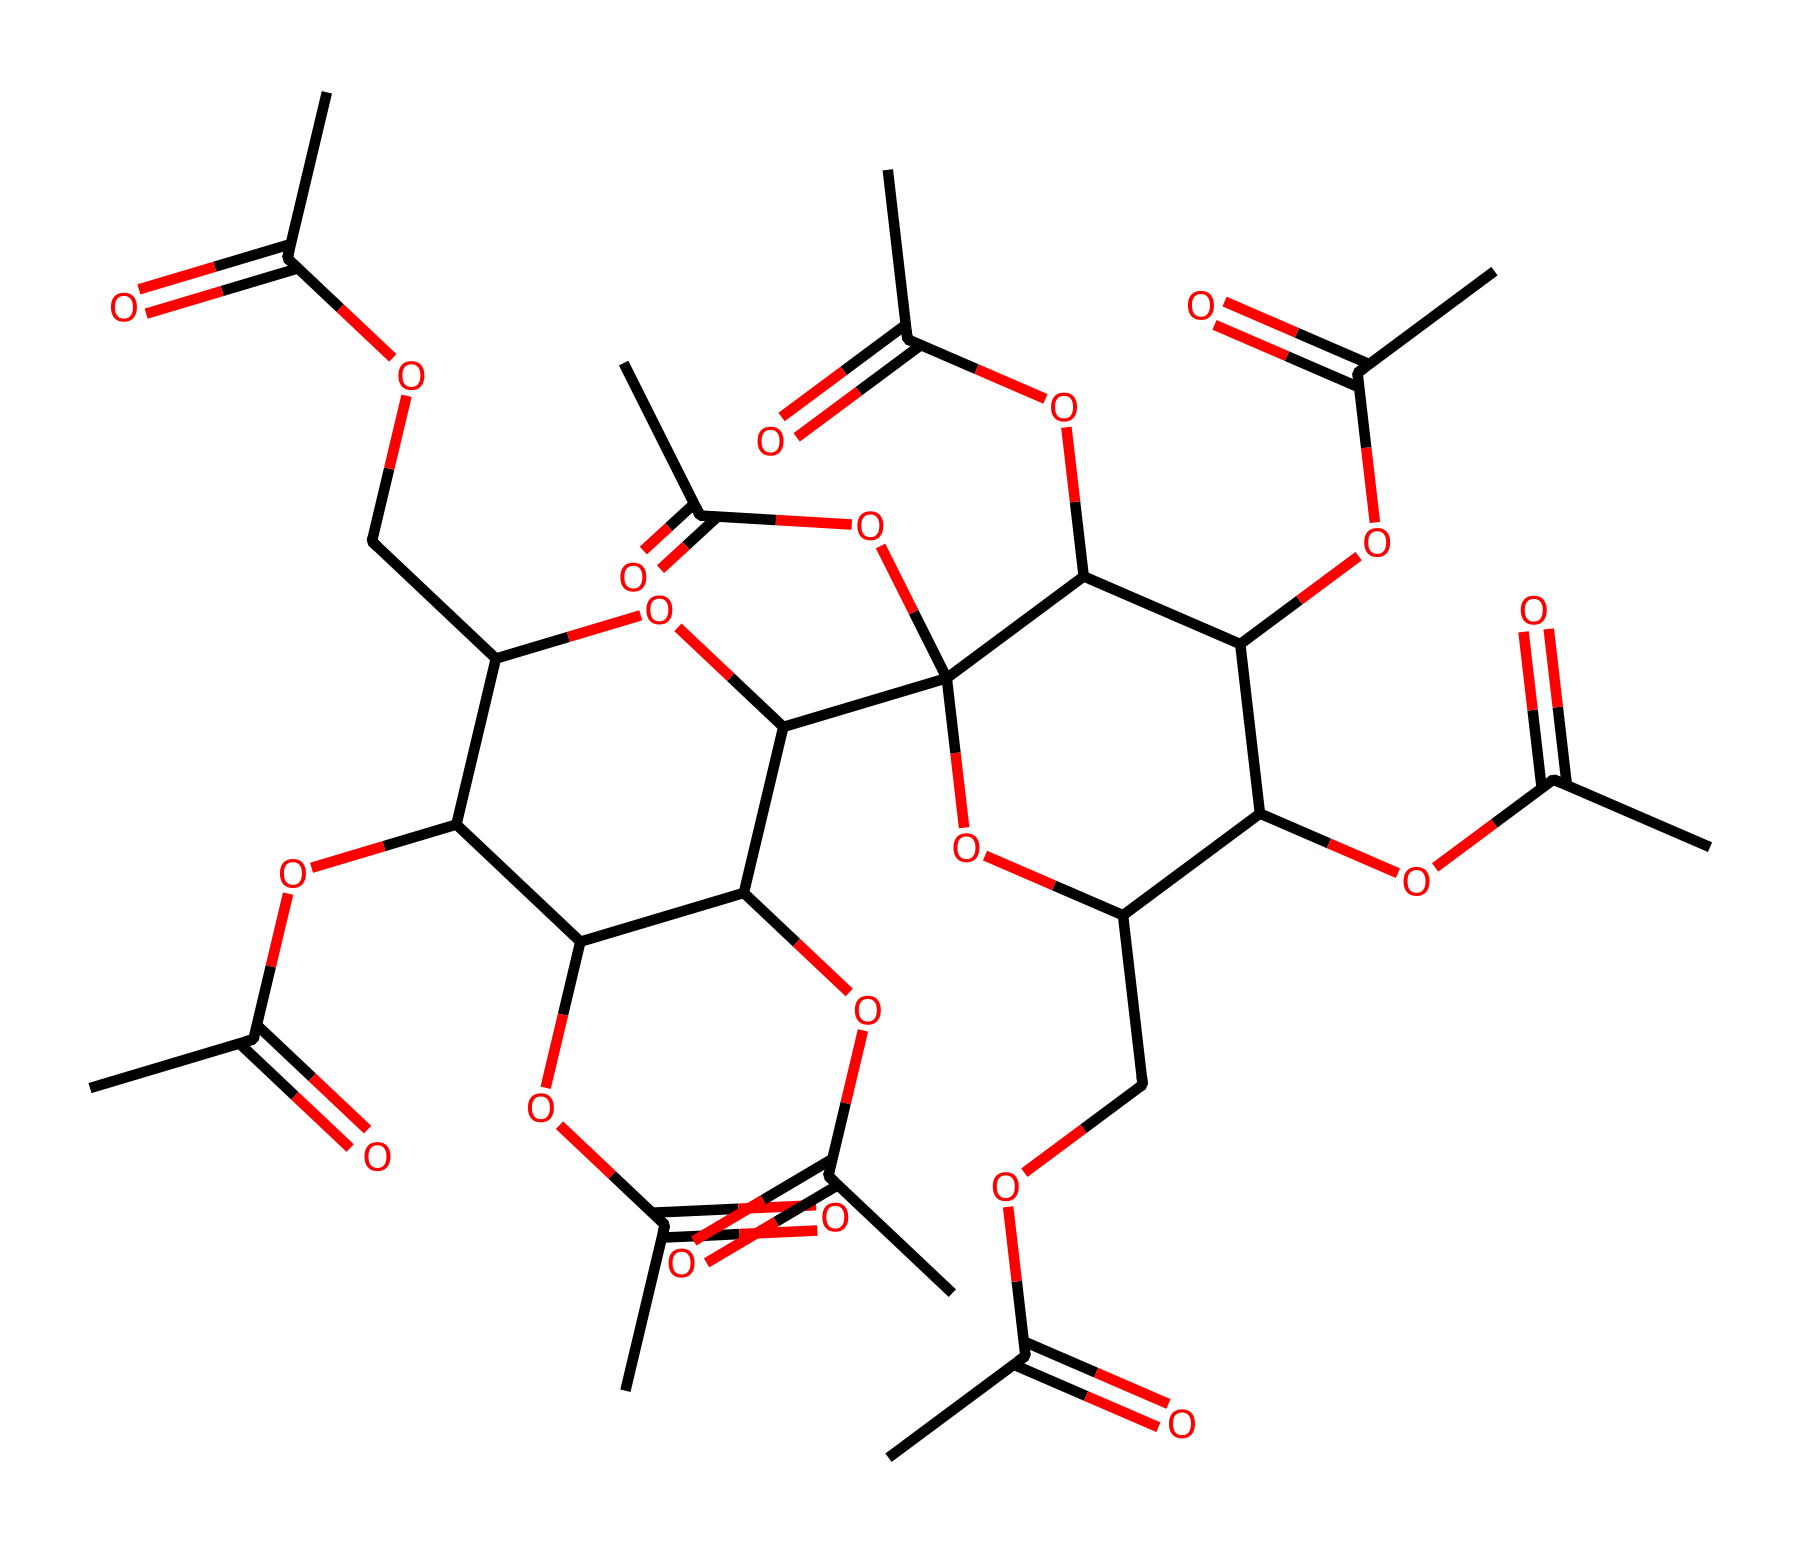What is the main functional group present in this structure? The main functional group in this structure is an ester group, characterized by the presence of a carbonyl (C=O) bonded to an oxygen atom (O) which is connected to another carbon chain.
Answer: ester How many carbon atoms are present in this molecule? By analyzing the structure and counting all the carbon atoms represented in the SMILES, I determine there are 21 carbon atoms present.
Answer: 21 What is the degree of branching in this compound? The compound shows significant branching due to multiple ether linkages and acetate groups; specifically, there are at least eight branches owing to the presence of multiple acetate functionalities.
Answer: high Which type of ester is this compound specifically classified as? This compound is classified as a cellulose acetate, which is a type of biopolymer made by esterifying cellulose with acetic acid.
Answer: cellulose acetate What role does the acetic acid play in this structure? Acetic acid acts as a reagent that introduces the acetate groups to the cellulose backbone, thus forming the ester linkages that characterize cellulose acetate.
Answer: esterification What is the expected physical state of cellulose acetate at room temperature? Given its structure and properties as a polymer, cellulose acetate is generally expected to be in a solid state at room temperature.
Answer: solid 